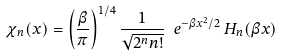Convert formula to latex. <formula><loc_0><loc_0><loc_500><loc_500>\chi _ { n } ( x ) = \left ( \frac { \beta } { \pi } \right ) ^ { 1 / 4 } \frac { 1 } { \sqrt { 2 ^ { n } n ! } } \ e ^ { - \beta x ^ { 2 } / 2 } \, H _ { n } ( \beta x )</formula> 